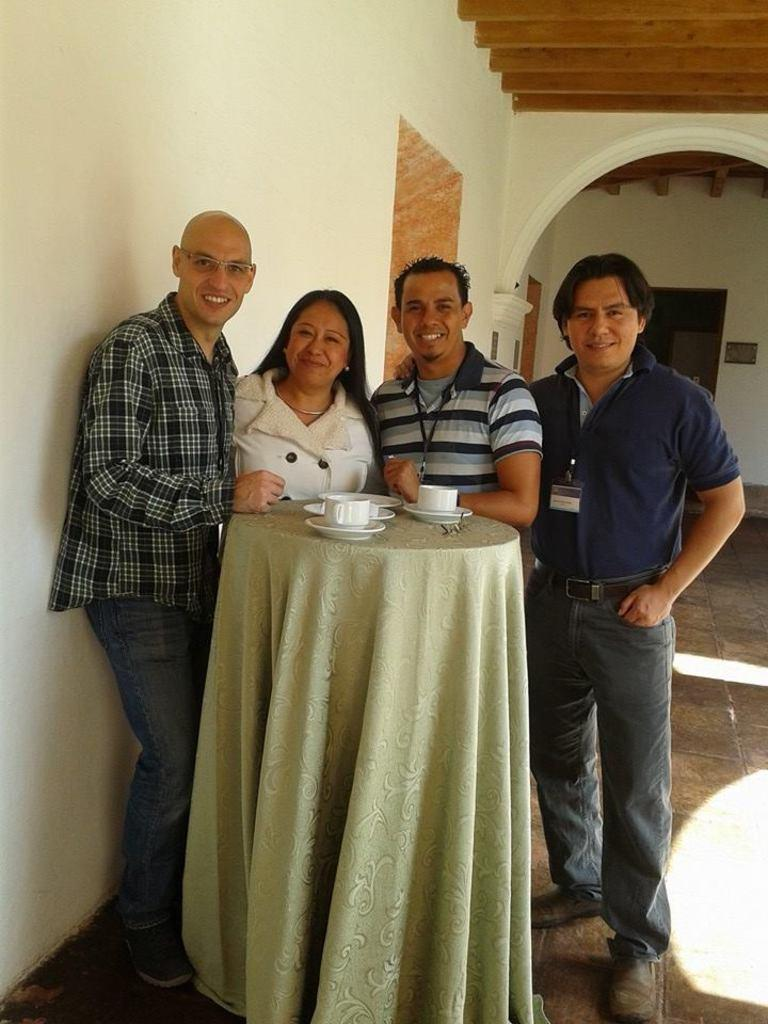How many people are standing in the image? There are four persons standing in the image. What is in front of the standing persons? There is a table in front of them. What can be seen on the table? The table has cups on it, and there are other objects on the table. What is the color of the wall in the image? The color of the wall is white. What type of soap is on the table in the image? There is no soap present on the table in the image. What color is the shirt worn by the person on the left? The provided facts do not mention any shirts or colors worn by the persons in the image. 